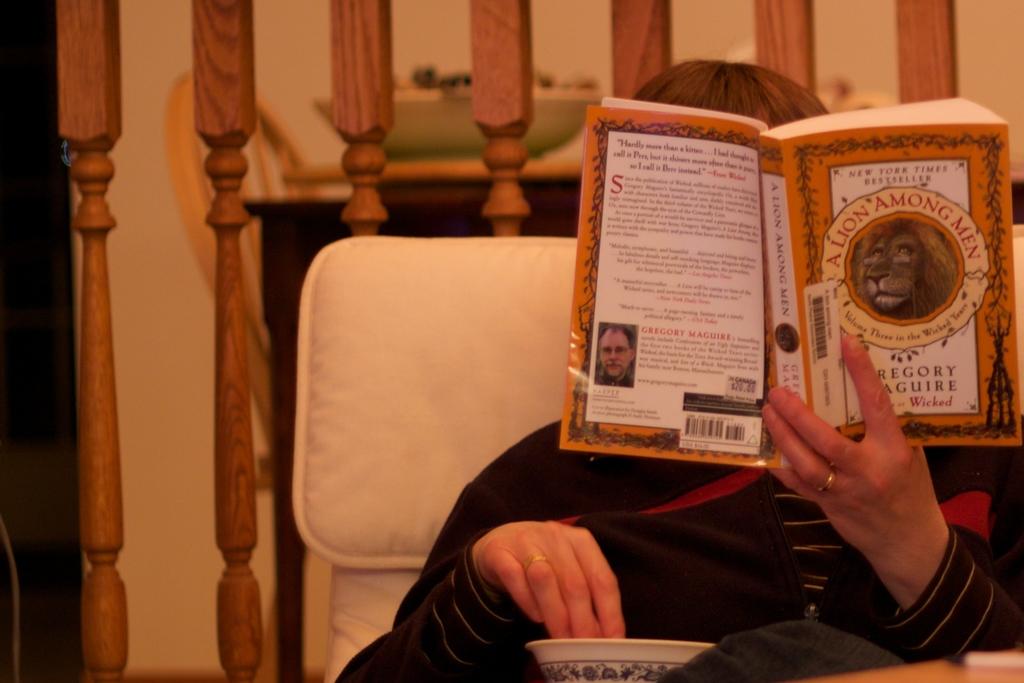What is she holding?
Provide a succinct answer. A lion among men. 